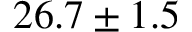Convert formula to latex. <formula><loc_0><loc_0><loc_500><loc_500>{ 2 6 . 7 \pm 1 . 5 }</formula> 